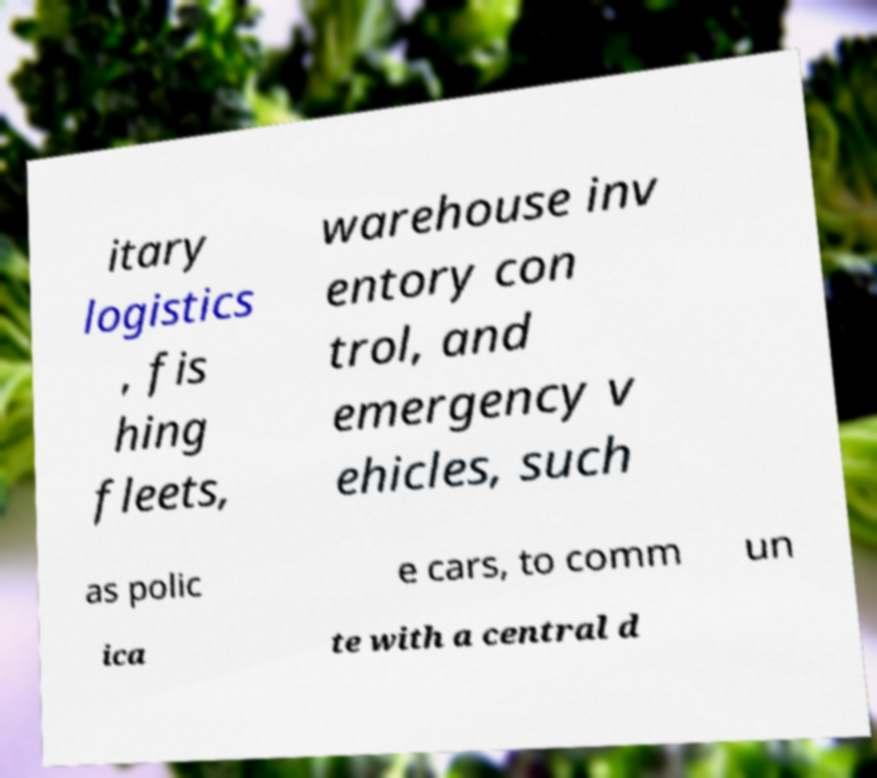Can you read and provide the text displayed in the image?This photo seems to have some interesting text. Can you extract and type it out for me? itary logistics , fis hing fleets, warehouse inv entory con trol, and emergency v ehicles, such as polic e cars, to comm un ica te with a central d 